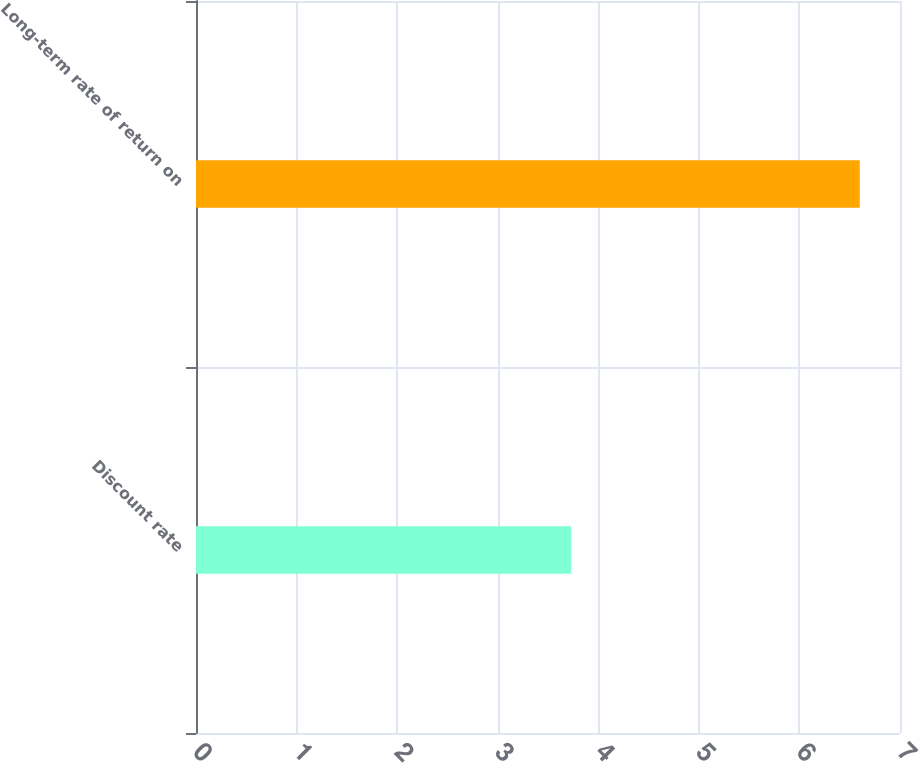Convert chart. <chart><loc_0><loc_0><loc_500><loc_500><bar_chart><fcel>Discount rate<fcel>Long-term rate of return on<nl><fcel>3.73<fcel>6.6<nl></chart> 